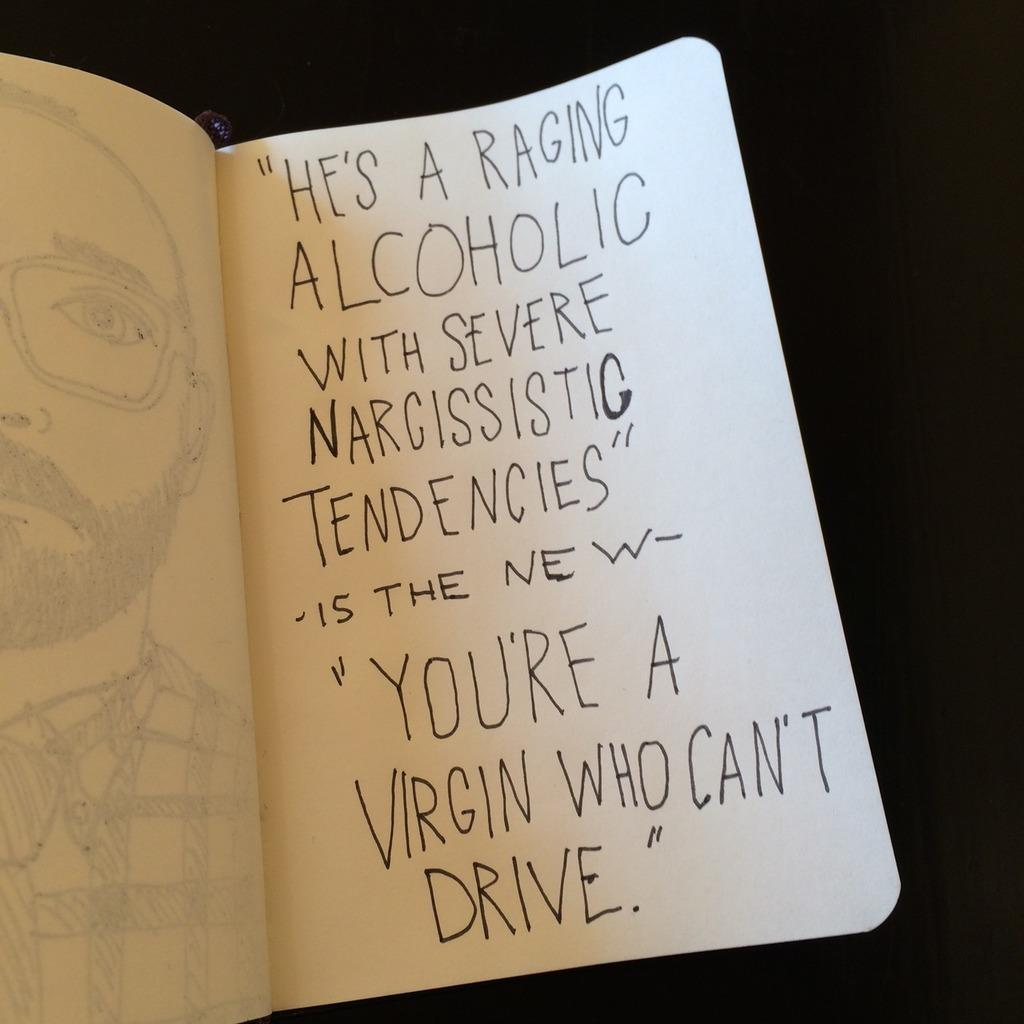<image>
Relay a brief, clear account of the picture shown. A book that states "HE'S A RAGING ALCOHOLIC WITH SEVERE NARCISSISTIC TENDENCIES" 